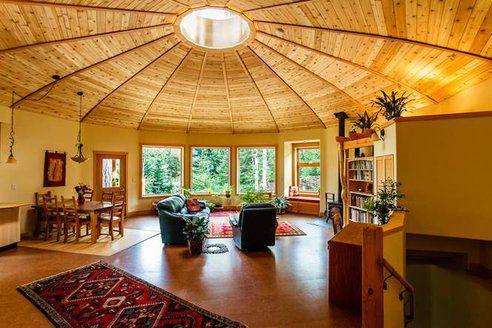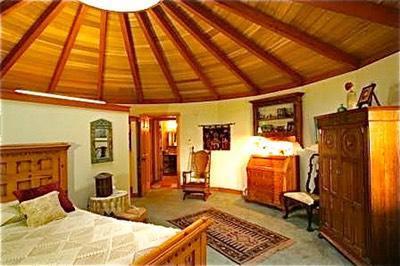The first image is the image on the left, the second image is the image on the right. Assess this claim about the two images: "At least one room has a patterned oriental-type rug on the floor.". Correct or not? Answer yes or no. Yes. 